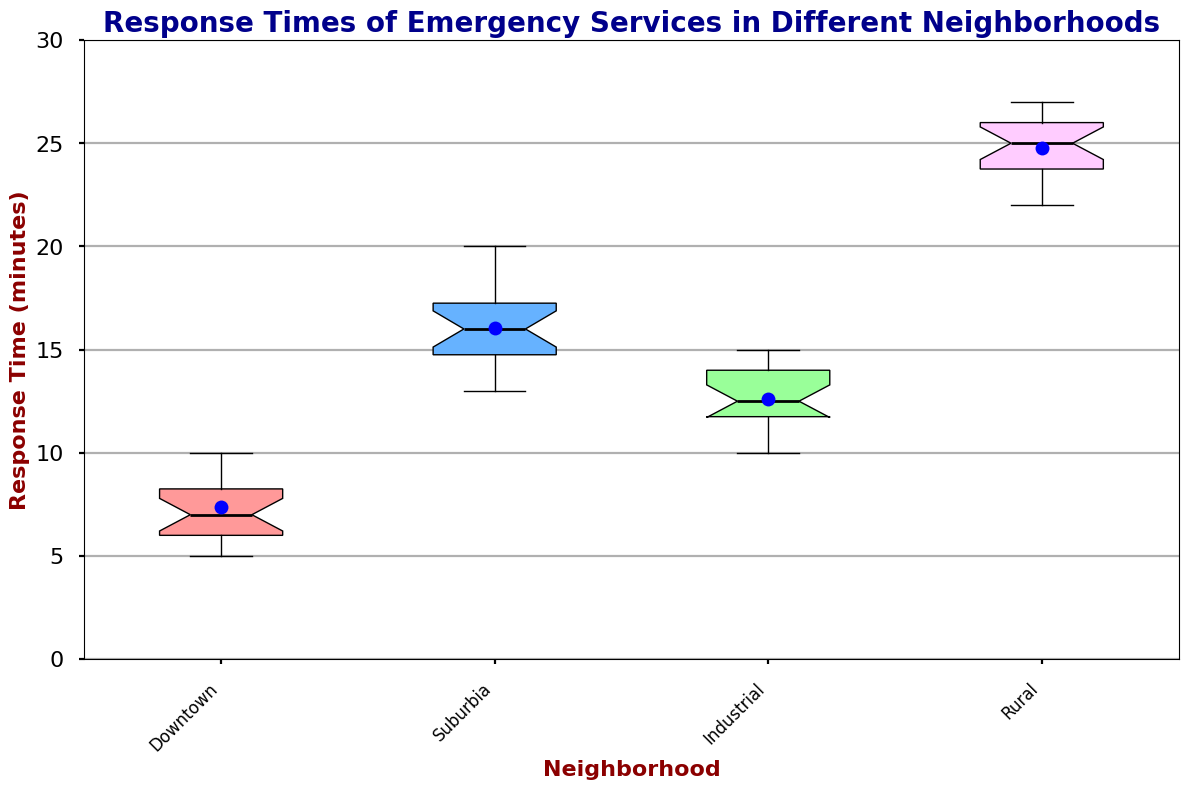What is the median response time for Downtown? The figure shows a box plot with a line in the middle of each box representing the median. For Downtown, this median line is at 7 minutes.
Answer: 7 Which neighborhood has the highest median response time? The highest median response time can be identified by comparing the positions of the median lines in each box. The Rural area has the highest median, which is around 25 minutes.
Answer: Rural What is the interquartile range (IQR) for Suburbia? The IQR is the range between the first quartile (Q1) and the third quartile (Q3). For Suburbia, Q1 is 14 and Q3 is 17, thus, the IQR = Q3 - Q1 = 17 - 14 = 3 minutes.
Answer: 3 How do the mean response times compare between Downtown and Industrial neighborhoods? The box plot shows a blue dot representing the mean. For Downtown, the mean is around 7 minutes and for Industrial, it appears to be about 12 minutes.
Answer: Downtown: 7, Industrial: 12 Which neighborhood has the widest range of response times? The range is the difference between the maximum and minimum response times, marked by the whiskers of the box plot. Rural has the widest range, with the maximum at 27 minutes and minimum at 22 minutes.
Answer: Rural What is the minimum response time recorded for the Industrial neighborhood? The whiskers of the box plot show the minimum value. For Industrial, the minimum response time is 10 minutes.
Answer: 10 Is there any overlap in the interquartile ranges of Suburbia and Rural neighborhoods? By observing the boxes indicating Q1 to Q3, we see no overlap because Rural's range is from 23 to 26 while Suburbia’s is from 14 to 17.
Answer: No overlap Which neighborhood has the smallest mean response time? The smallest mean is represented by the lowest blue dot on each box. Downtown has the smallest mean response time, at approximately 7 minutes.
Answer: Downtown In which neighborhood does the response time vary the most? The degree of variation is indicated by the length of the whiskers and the spread of the box. Rural, with a range of 22 to 27, indicates the greatest variation.
Answer: Rural 